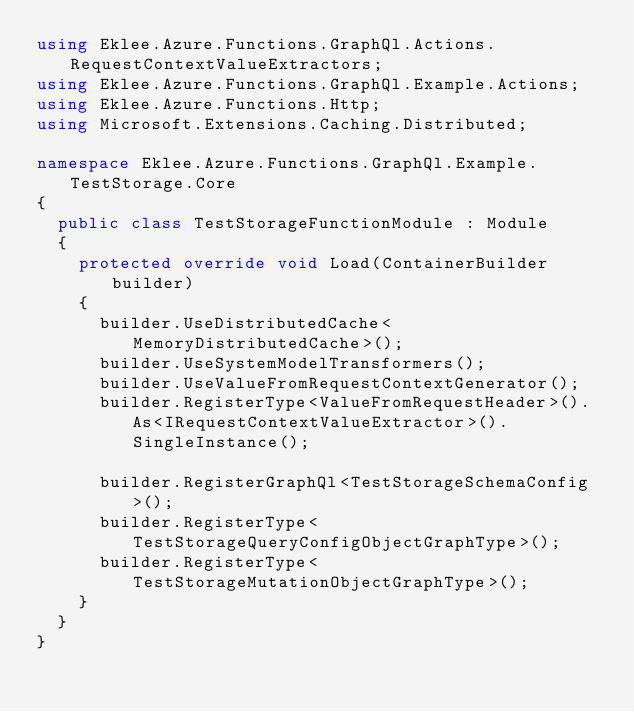Convert code to text. <code><loc_0><loc_0><loc_500><loc_500><_C#_>using Eklee.Azure.Functions.GraphQl.Actions.RequestContextValueExtractors;
using Eklee.Azure.Functions.GraphQl.Example.Actions;
using Eklee.Azure.Functions.Http;
using Microsoft.Extensions.Caching.Distributed;

namespace Eklee.Azure.Functions.GraphQl.Example.TestStorage.Core
{
	public class TestStorageFunctionModule : Module
	{
		protected override void Load(ContainerBuilder builder)
		{
			builder.UseDistributedCache<MemoryDistributedCache>();
			builder.UseSystemModelTransformers();
			builder.UseValueFromRequestContextGenerator();
			builder.RegisterType<ValueFromRequestHeader>().As<IRequestContextValueExtractor>().SingleInstance();

			builder.RegisterGraphQl<TestStorageSchemaConfig>();
			builder.RegisterType<TestStorageQueryConfigObjectGraphType>();
			builder.RegisterType<TestStorageMutationObjectGraphType>();
		}
	}
}
</code> 